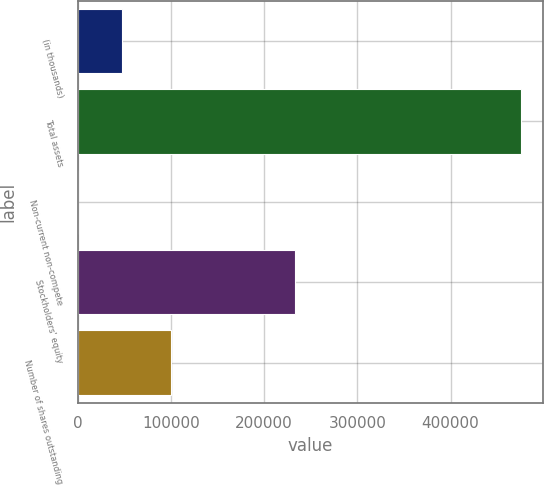<chart> <loc_0><loc_0><loc_500><loc_500><bar_chart><fcel>(in thousands)<fcel>Total assets<fcel>Non-current non-compete<fcel>Stockholders' equity<fcel>Number of shares outstanding<nl><fcel>48220.3<fcel>475228<fcel>775<fcel>233553<fcel>100636<nl></chart> 